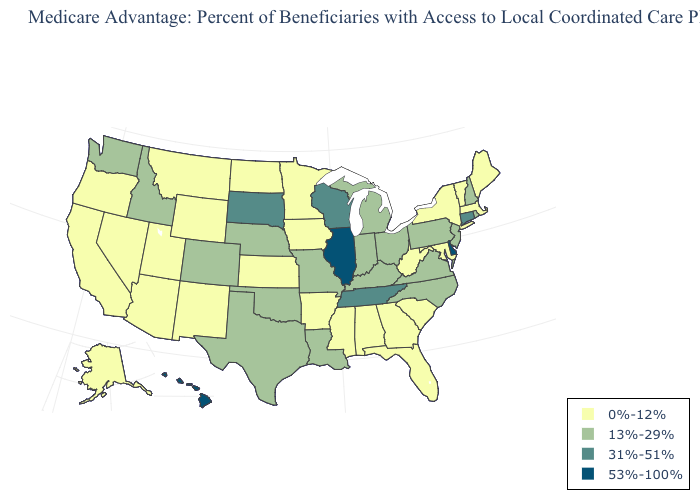Name the states that have a value in the range 13%-29%?
Quick response, please. Colorado, Idaho, Indiana, Kentucky, Louisiana, Michigan, Missouri, North Carolina, Nebraska, New Hampshire, New Jersey, Ohio, Oklahoma, Pennsylvania, Rhode Island, Texas, Virginia, Washington. What is the value of North Dakota?
Be succinct. 0%-12%. What is the value of Virginia?
Keep it brief. 13%-29%. What is the lowest value in states that border New Mexico?
Keep it brief. 0%-12%. What is the lowest value in states that border Tennessee?
Write a very short answer. 0%-12%. Among the states that border Arkansas , which have the lowest value?
Write a very short answer. Mississippi. Name the states that have a value in the range 13%-29%?
Short answer required. Colorado, Idaho, Indiana, Kentucky, Louisiana, Michigan, Missouri, North Carolina, Nebraska, New Hampshire, New Jersey, Ohio, Oklahoma, Pennsylvania, Rhode Island, Texas, Virginia, Washington. What is the value of Wisconsin?
Concise answer only. 31%-51%. Name the states that have a value in the range 13%-29%?
Concise answer only. Colorado, Idaho, Indiana, Kentucky, Louisiana, Michigan, Missouri, North Carolina, Nebraska, New Hampshire, New Jersey, Ohio, Oklahoma, Pennsylvania, Rhode Island, Texas, Virginia, Washington. What is the value of Illinois?
Keep it brief. 53%-100%. What is the highest value in states that border Indiana?
Write a very short answer. 53%-100%. Does Rhode Island have the highest value in the Northeast?
Keep it brief. No. How many symbols are there in the legend?
Be succinct. 4. Does Oregon have the lowest value in the West?
Concise answer only. Yes. 